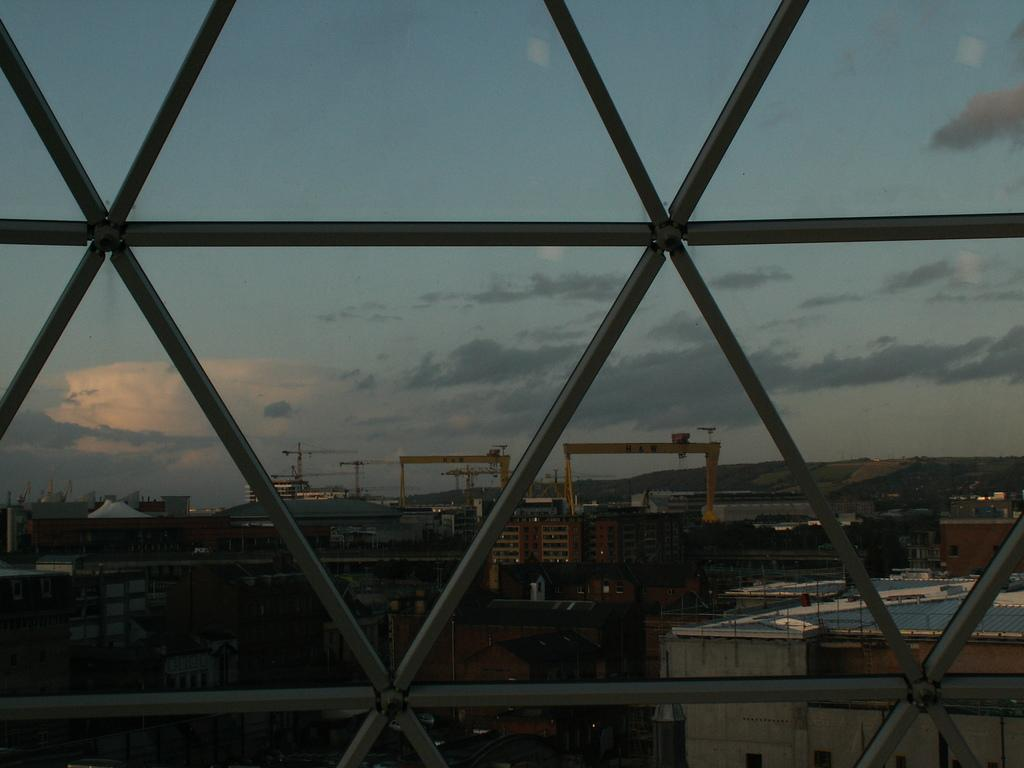What type of structures can be seen in the image? There are buildings in the image. What construction equipment is visible in the image? There are cranes in the image. What vertical structures can be seen in the image? There are poles in the image. What type of vegetation is present in the image? There are trees in the image. What part of the natural environment is visible in the image? The sky is visible in the image. What type of hat is the tree wearing in the image? There is no hat present in the image; it features trees without any accessories. How does the acoustics of the buildings affect the sound in the image? The provided facts do not mention anything about the acoustics of the buildings, so it cannot be determined from the image. 